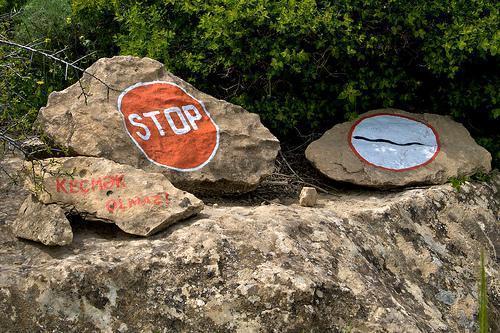How many signs are there?
Give a very brief answer. 2. 